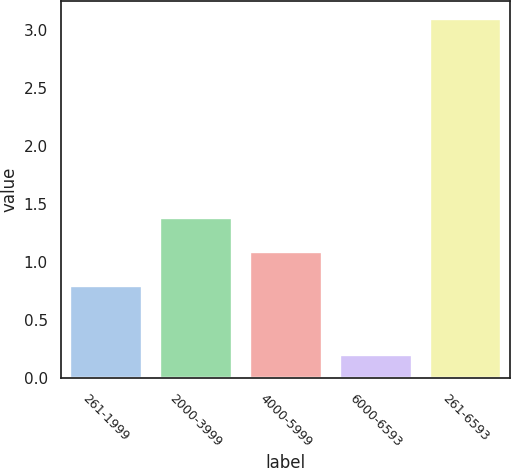<chart> <loc_0><loc_0><loc_500><loc_500><bar_chart><fcel>261-1999<fcel>2000-3999<fcel>4000-5999<fcel>6000-6593<fcel>261-6593<nl><fcel>0.8<fcel>1.38<fcel>1.09<fcel>0.2<fcel>3.1<nl></chart> 